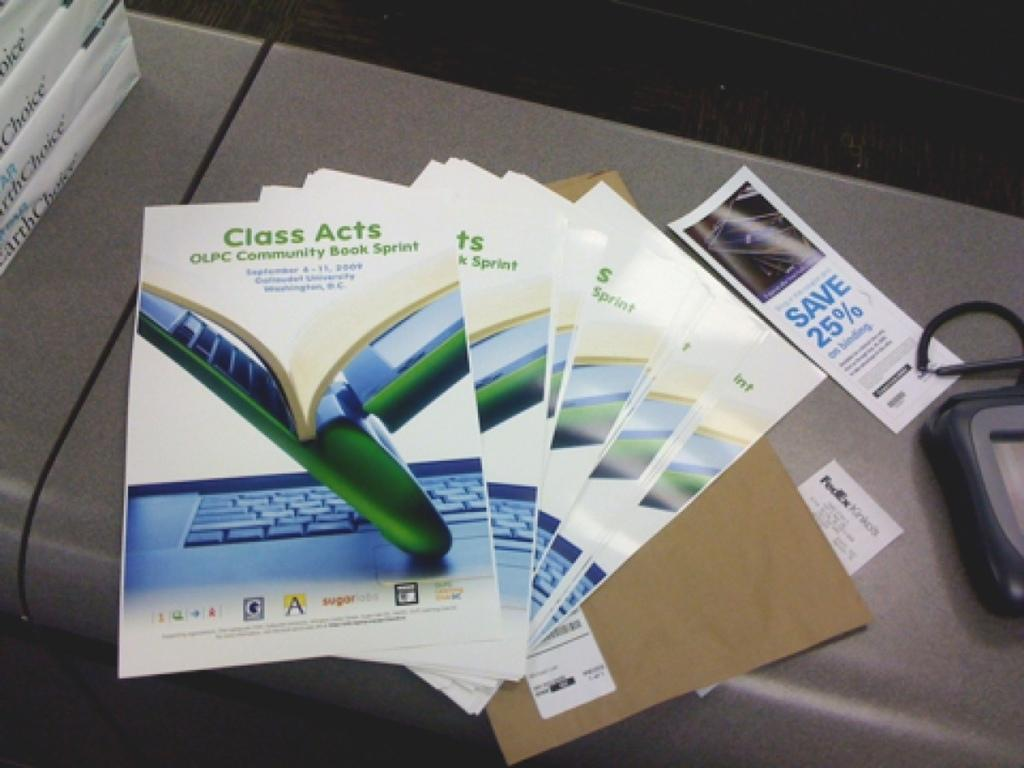<image>
Render a clear and concise summary of the photo. Class acts is written on a pamphlet with several identical ones. 